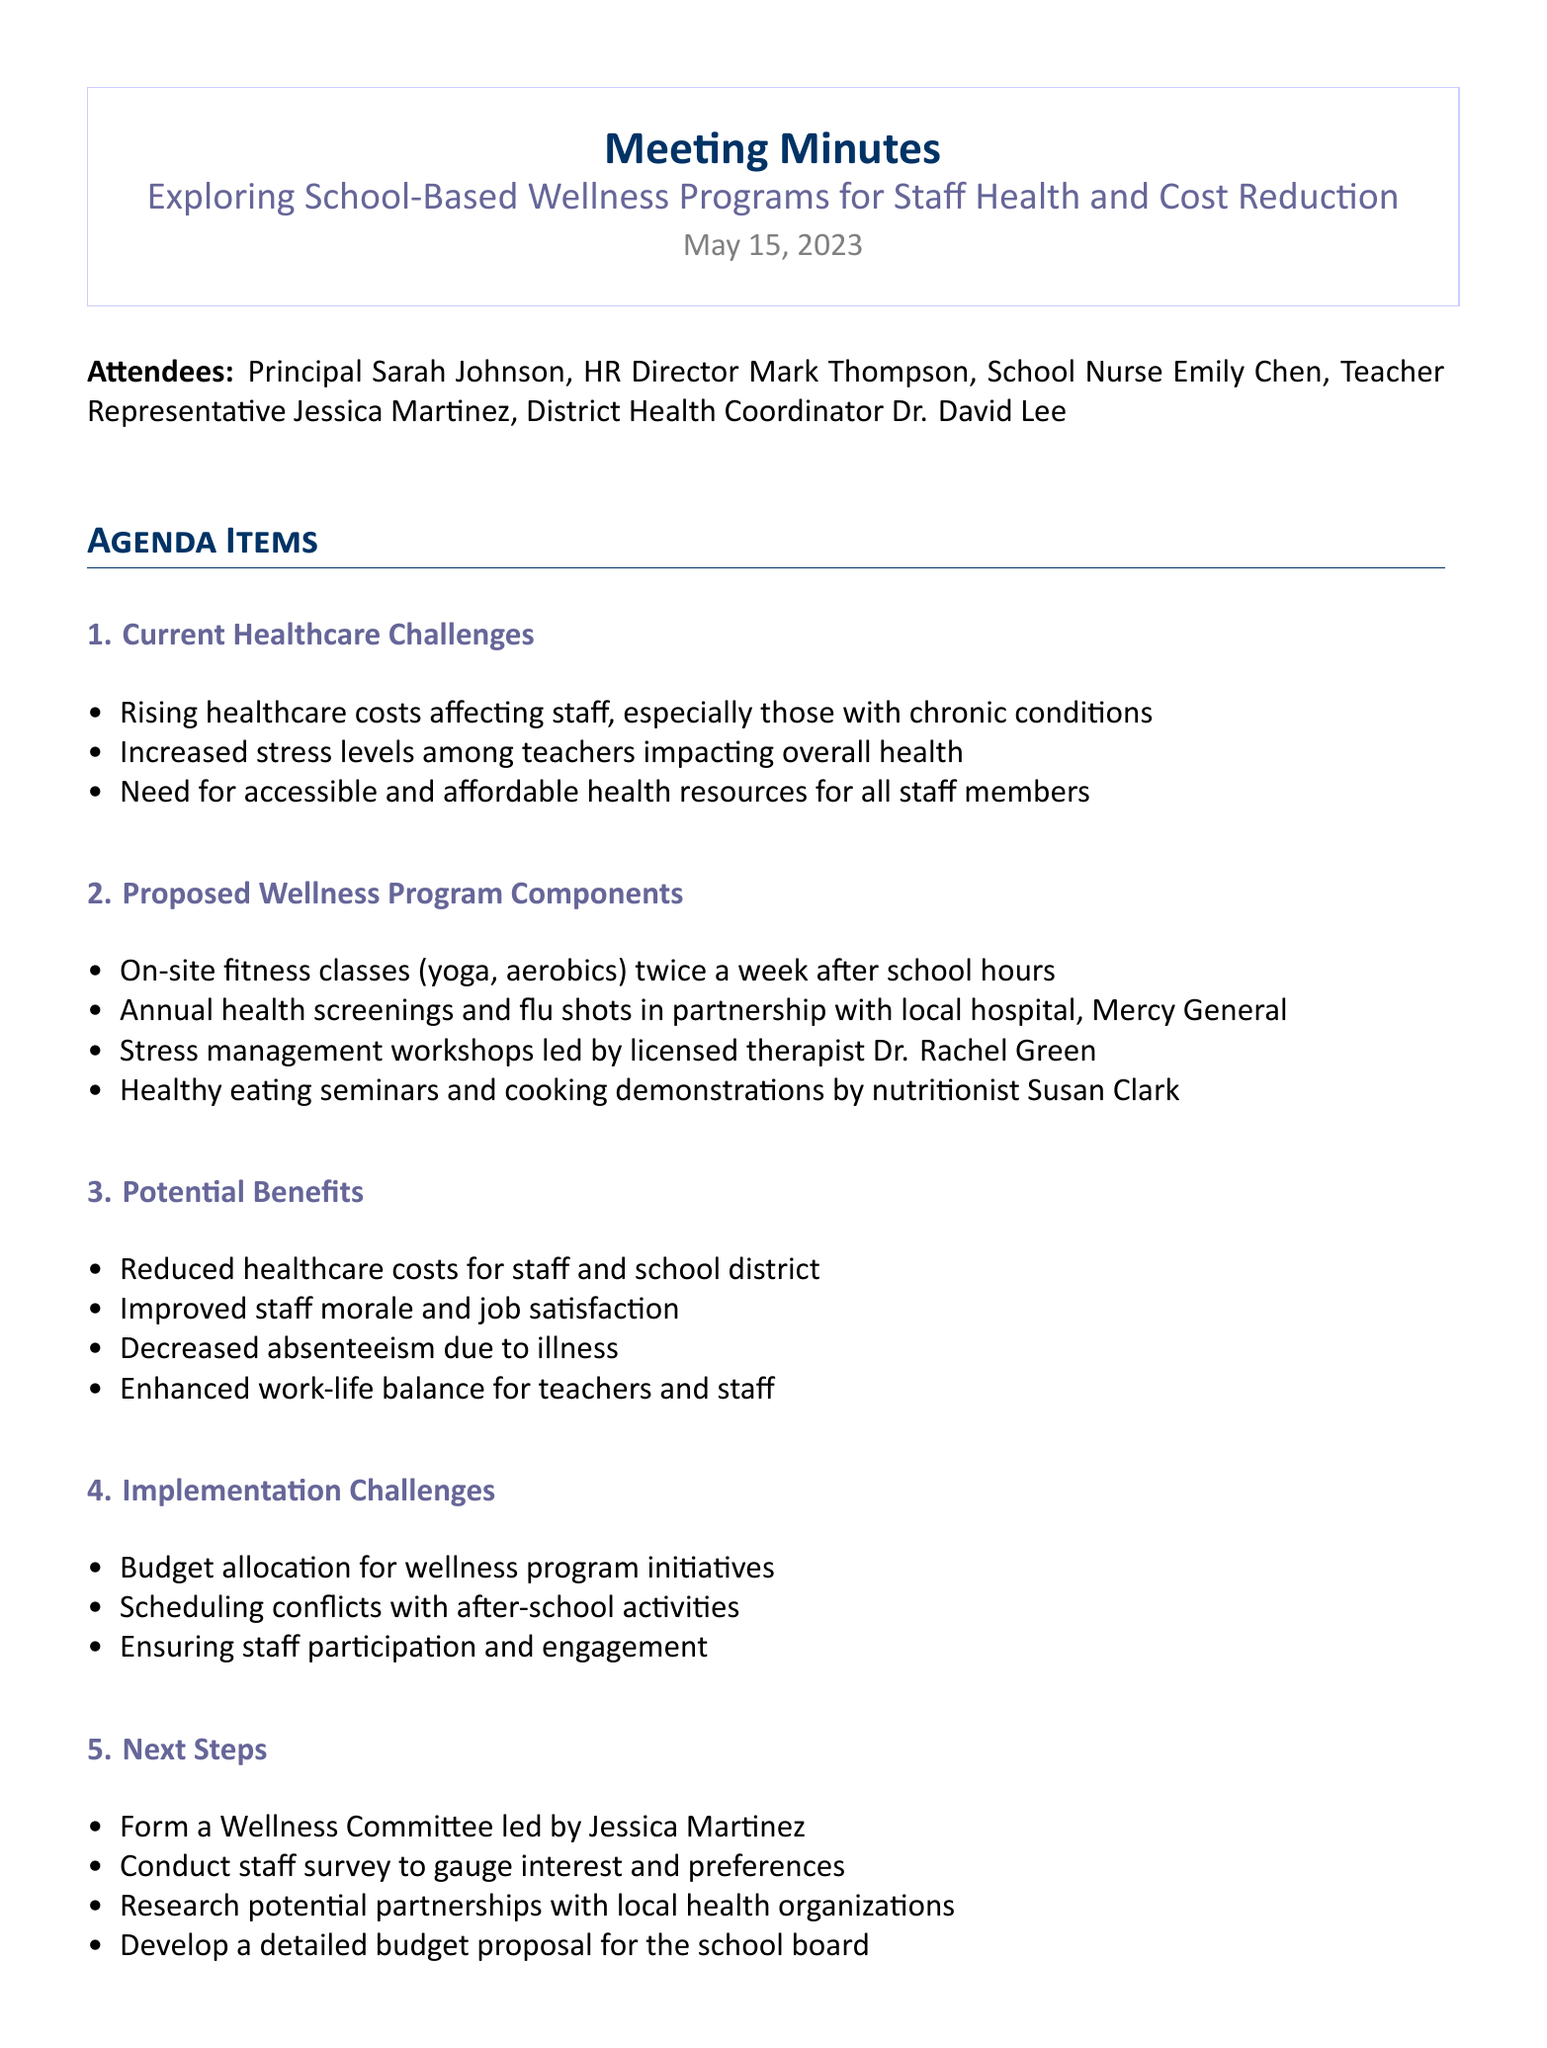What is the date of the meeting? The date of the meeting is stated at the beginning of the document.
Answer: May 15, 2023 Who is leading the Wellness Committee? This information is found in the "Next Steps" section of the document.
Answer: Jessica Martinez What are two proposed wellness program components? The question refers to the list of components in the "Proposed Wellness Program Components" section.
Answer: On-site fitness classes, annual health screenings What are the potential benefits mentioned in the document? This relates to the "Potential Benefits" section where various benefits are outlined.
Answer: Reduced healthcare costs, improved staff morale What is one implementation challenge discussed? This question asks for specific challenges listed under "Implementation Challenges."
Answer: Budget allocation How many attendees were present at the meeting? Attendee names are listed at the beginning of the document.
Answer: Five What action item corresponds to health screening options? The action items specify who is responsible for what tasks regarding the wellness program.
Answer: Emily Chen to reach out to Mercy General Which health organization is mentioned for partnership? The document mentions the organization in the context of wellness program components.
Answer: Mercy General 